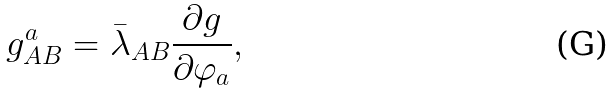<formula> <loc_0><loc_0><loc_500><loc_500>g _ { A B } ^ { a } = \bar { \lambda } _ { A B } \frac { \partial g } { \partial \varphi _ { a } } ,</formula> 